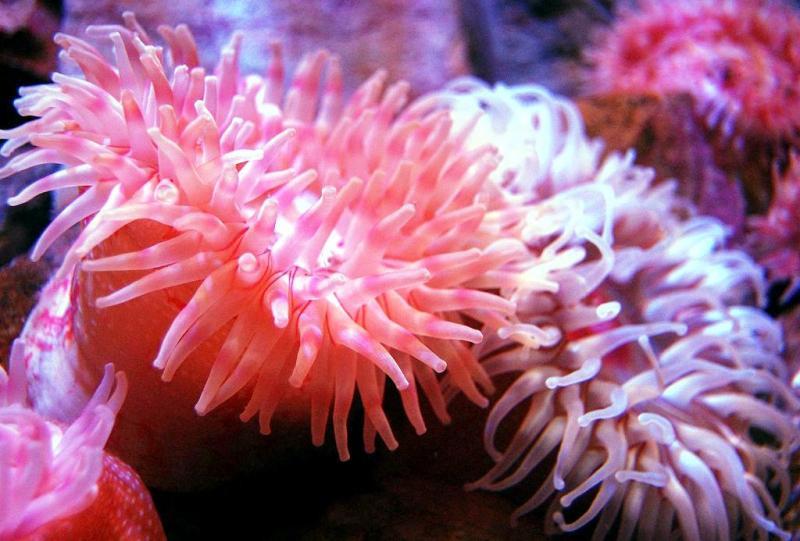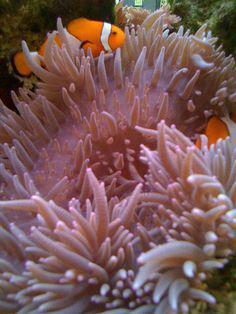The first image is the image on the left, the second image is the image on the right. For the images displayed, is the sentence "Looking down from the top angle, into the colorful anemone pictured in the image on the right, reveals a central, mouth-like opening, surrounded by tentacles." factually correct? Answer yes or no. No. 